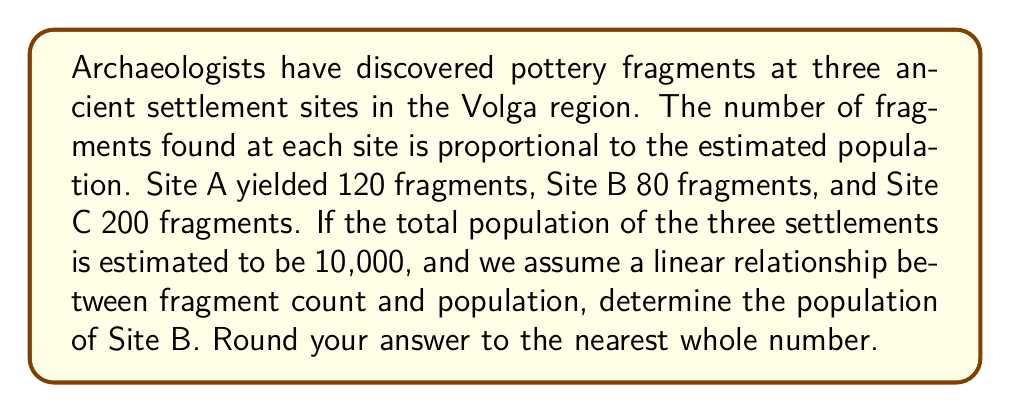Teach me how to tackle this problem. Let's approach this step-by-step:

1) First, we need to establish the relationship between fragment count and population. Let's define a constant $k$ such that:

   $\text{Population} = k \times \text{Fragment Count}$

2) We know the total population is 10,000, so we can set up an equation:

   $10,000 = k(120 + 80 + 200)$

3) Simplify:

   $10,000 = 400k$

4) Solve for $k$:

   $k = \frac{10,000}{400} = 25$

5) This means each fragment represents 25 people.

6) For Site B, which has 80 fragments, we can calculate:

   $\text{Population}_B = 25 \times 80 = 2,000$

Therefore, the population of Site B is estimated to be 2,000 people.

This linear model, while simplistic, provides a basis for population estimation in archaeological contexts. However, it's important to note that in reality, the relationship between artifact count and population might be more complex, influenced by factors such as settlement longevity, preservation conditions, and cultural practices.
Answer: 2,000 